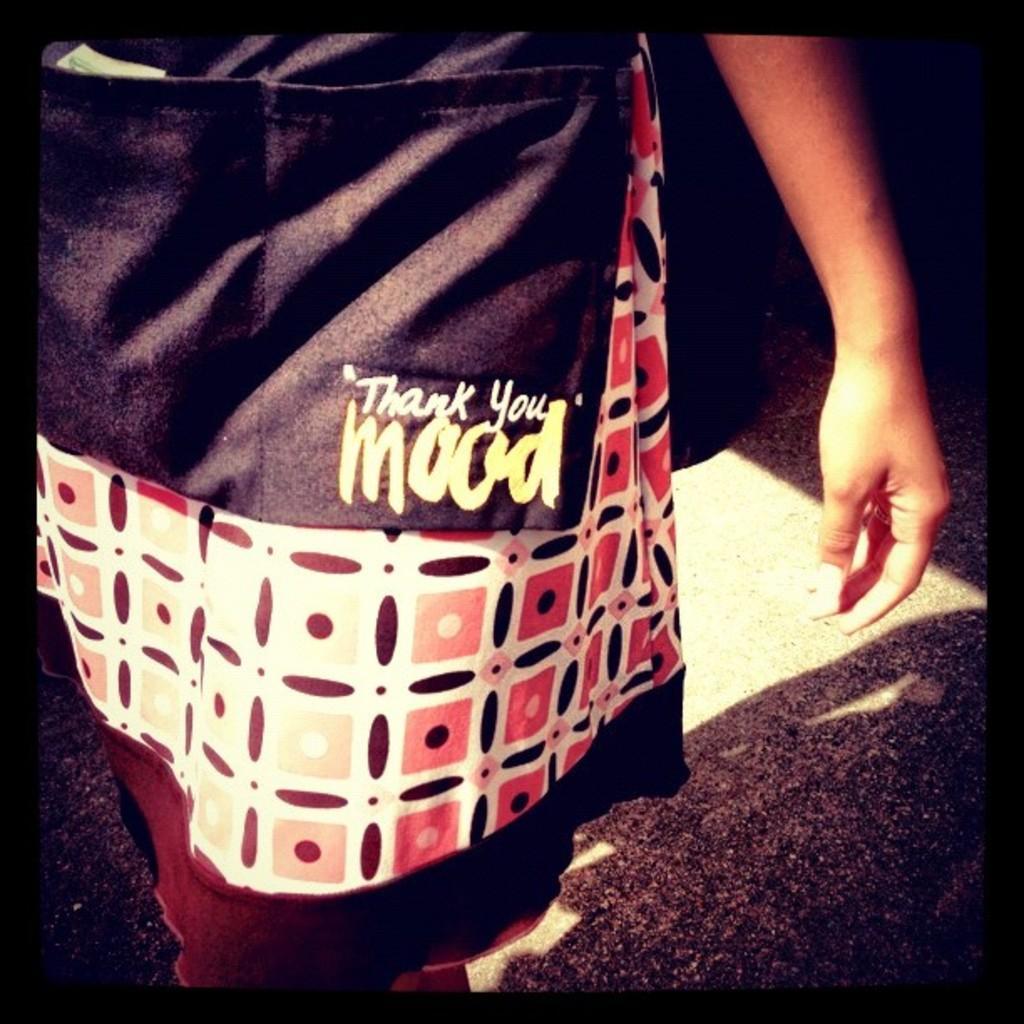Please provide a concise description of this image. In this image, we can see a person whose face is not visible wearing clothes. 